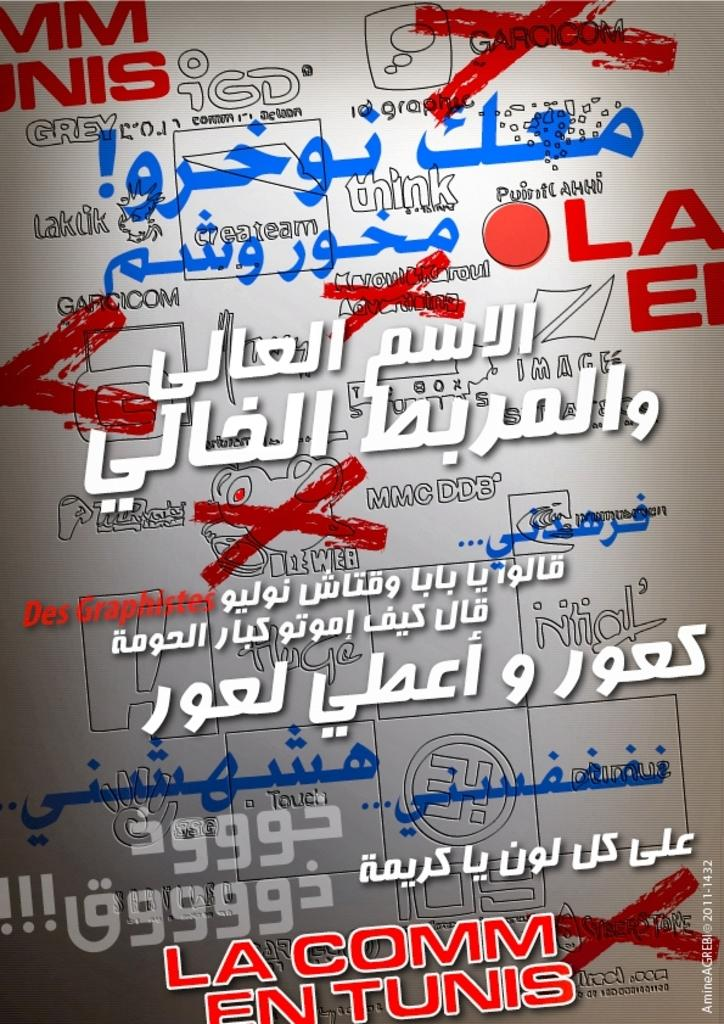What can be seen in the image related to text? There is writing in the image. Can you describe the characteristics of the writing? The writing is in different languages and different colors. What type of pet can be seen interacting with the writing in the image? There is no pet present in the image, and the writing is not being interacted with. 